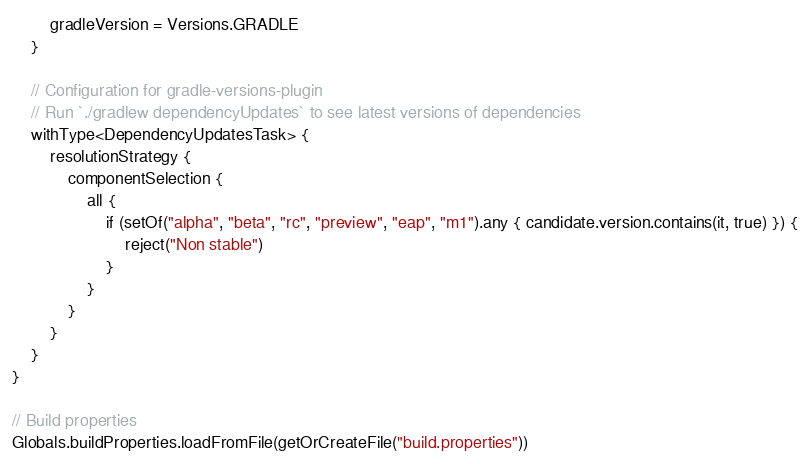Convert code to text. <code><loc_0><loc_0><loc_500><loc_500><_Kotlin_>        gradleVersion = Versions.GRADLE
    }

    // Configuration for gradle-versions-plugin
    // Run `./gradlew dependencyUpdates` to see latest versions of dependencies
    withType<DependencyUpdatesTask> {
        resolutionStrategy {
            componentSelection {
                all {
                    if (setOf("alpha", "beta", "rc", "preview", "eap", "m1").any { candidate.version.contains(it, true) }) {
                        reject("Non stable")
                    }
                }
            }
        }
    }
}

// Build properties
Globals.buildProperties.loadFromFile(getOrCreateFile("build.properties"))
</code> 